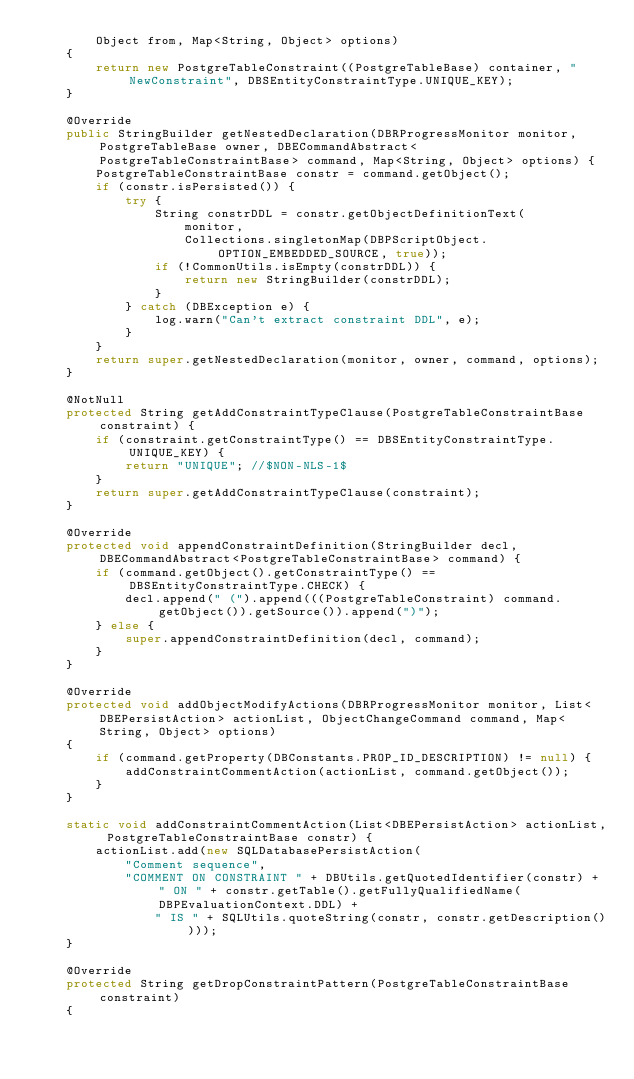<code> <loc_0><loc_0><loc_500><loc_500><_Java_>        Object from, Map<String, Object> options)
    {
        return new PostgreTableConstraint((PostgreTableBase) container, "NewConstraint", DBSEntityConstraintType.UNIQUE_KEY);
    }

    @Override
    public StringBuilder getNestedDeclaration(DBRProgressMonitor monitor, PostgreTableBase owner, DBECommandAbstract<PostgreTableConstraintBase> command, Map<String, Object> options) {
        PostgreTableConstraintBase constr = command.getObject();
        if (constr.isPersisted()) {
            try {
                String constrDDL = constr.getObjectDefinitionText(
                    monitor,
                    Collections.singletonMap(DBPScriptObject.OPTION_EMBEDDED_SOURCE, true));
                if (!CommonUtils.isEmpty(constrDDL)) {
                    return new StringBuilder(constrDDL);
                }
            } catch (DBException e) {
                log.warn("Can't extract constraint DDL", e);
            }
        }
        return super.getNestedDeclaration(monitor, owner, command, options);
    }

    @NotNull
    protected String getAddConstraintTypeClause(PostgreTableConstraintBase constraint) {
        if (constraint.getConstraintType() == DBSEntityConstraintType.UNIQUE_KEY) {
            return "UNIQUE"; //$NON-NLS-1$
        }
        return super.getAddConstraintTypeClause(constraint);
    }

    @Override
    protected void appendConstraintDefinition(StringBuilder decl, DBECommandAbstract<PostgreTableConstraintBase> command) {
        if (command.getObject().getConstraintType() == DBSEntityConstraintType.CHECK) {
            decl.append(" (").append(((PostgreTableConstraint) command.getObject()).getSource()).append(")");
        } else {
            super.appendConstraintDefinition(decl, command);
        }
    }

    @Override
    protected void addObjectModifyActions(DBRProgressMonitor monitor, List<DBEPersistAction> actionList, ObjectChangeCommand command, Map<String, Object> options)
    {
        if (command.getProperty(DBConstants.PROP_ID_DESCRIPTION) != null) {
            addConstraintCommentAction(actionList, command.getObject());
        }
    }

    static void addConstraintCommentAction(List<DBEPersistAction> actionList, PostgreTableConstraintBase constr) {
        actionList.add(new SQLDatabasePersistAction(
            "Comment sequence",
            "COMMENT ON CONSTRAINT " + DBUtils.getQuotedIdentifier(constr) + " ON " + constr.getTable().getFullyQualifiedName(DBPEvaluationContext.DDL) +
                " IS " + SQLUtils.quoteString(constr, constr.getDescription())));
    }

    @Override
    protected String getDropConstraintPattern(PostgreTableConstraintBase constraint)
    {</code> 